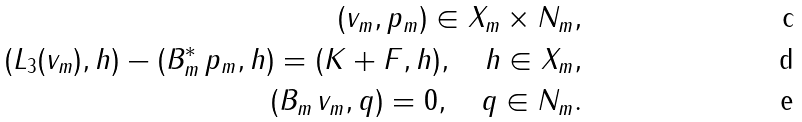Convert formula to latex. <formula><loc_0><loc_0><loc_500><loc_500>( v _ { m } , p _ { m } ) \in X _ { m } \times N _ { m } , \\ ( L _ { 3 } ( v _ { m } ) , h ) - ( B _ { m } ^ { * } \, p _ { m } , h ) = ( K + F , h ) , \quad h \in X _ { m } , \\ ( B _ { m } \, v _ { m } , q ) = 0 , \quad q \in N _ { m } .</formula> 